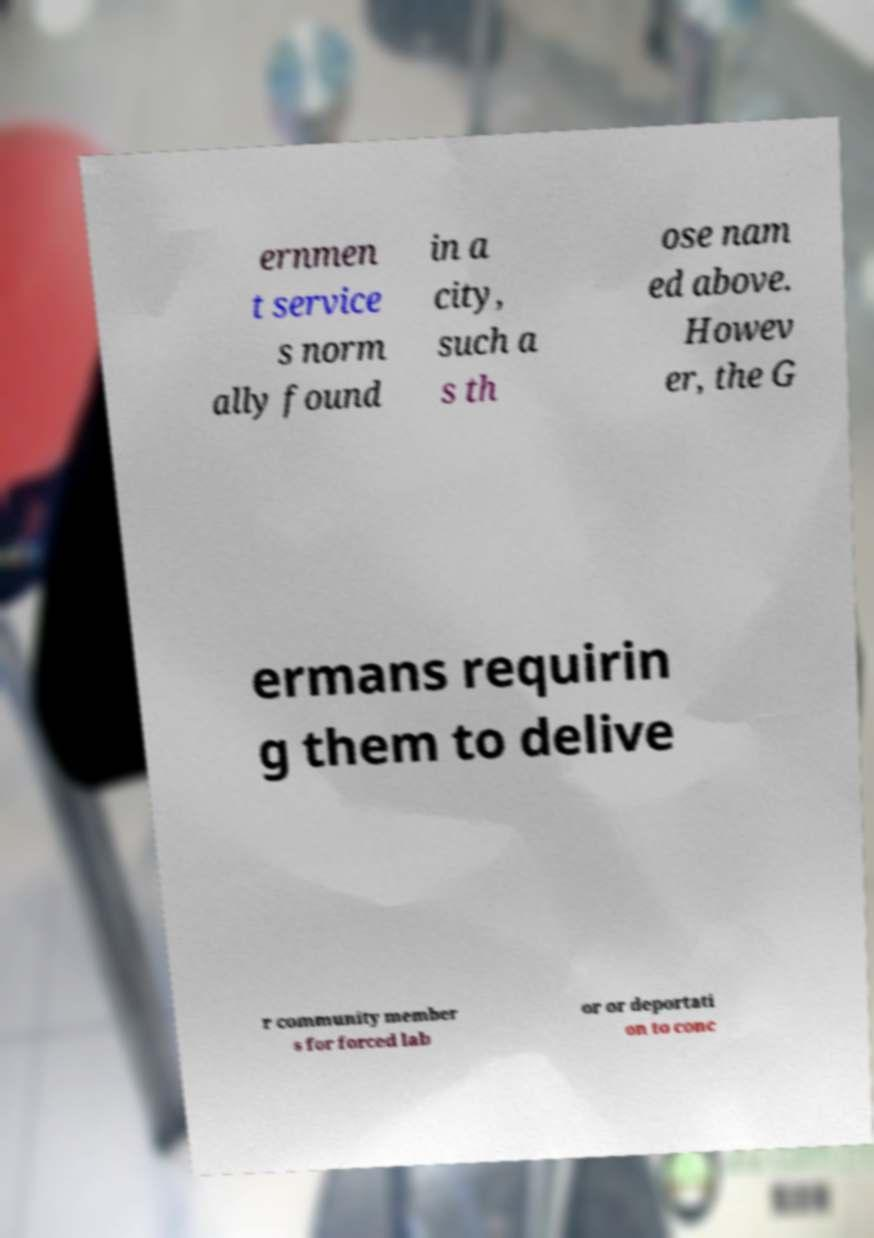Please identify and transcribe the text found in this image. ernmen t service s norm ally found in a city, such a s th ose nam ed above. Howev er, the G ermans requirin g them to delive r community member s for forced lab or or deportati on to conc 